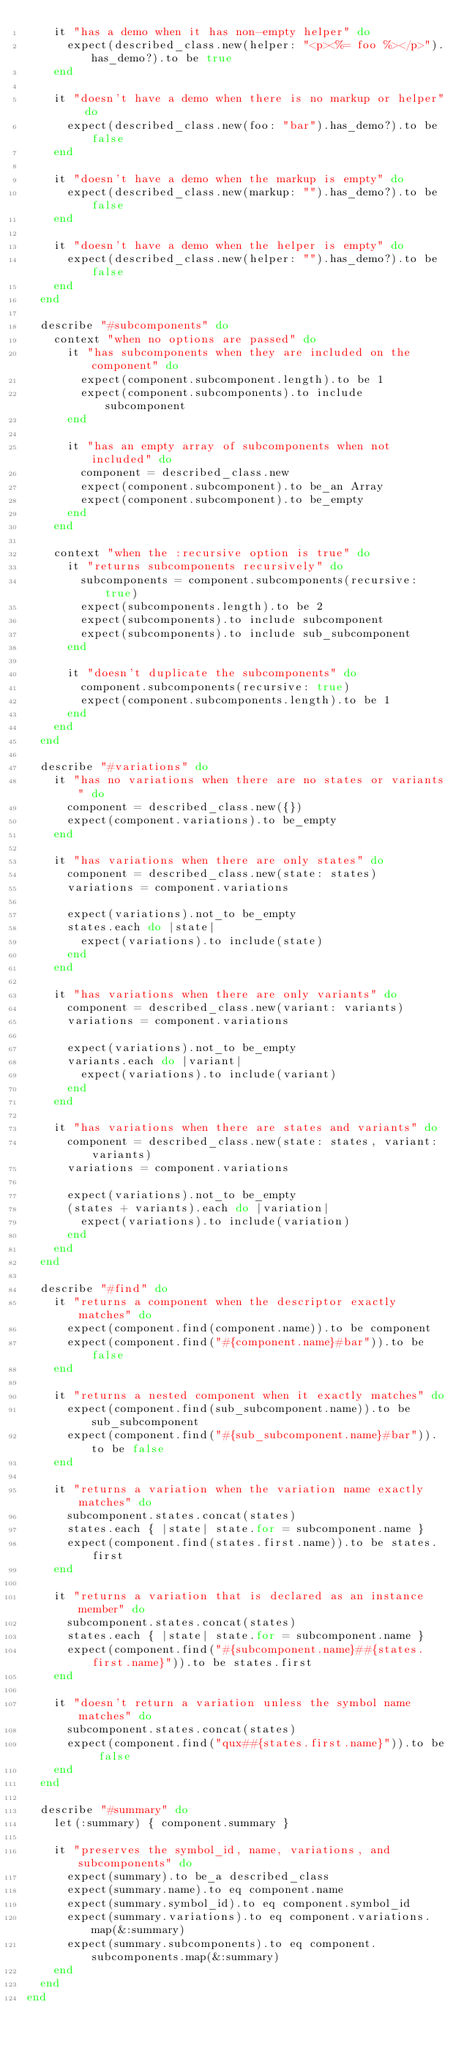Convert code to text. <code><loc_0><loc_0><loc_500><loc_500><_Ruby_>    it "has a demo when it has non-empty helper" do
      expect(described_class.new(helper: "<p><%= foo %></p>").has_demo?).to be true
    end

    it "doesn't have a demo when there is no markup or helper" do
      expect(described_class.new(foo: "bar").has_demo?).to be false
    end

    it "doesn't have a demo when the markup is empty" do
      expect(described_class.new(markup: "").has_demo?).to be false
    end

    it "doesn't have a demo when the helper is empty" do
      expect(described_class.new(helper: "").has_demo?).to be false
    end
  end

  describe "#subcomponents" do
    context "when no options are passed" do
      it "has subcomponents when they are included on the component" do
        expect(component.subcomponent.length).to be 1
        expect(component.subcomponents).to include subcomponent
      end

      it "has an empty array of subcomponents when not included" do
        component = described_class.new
        expect(component.subcomponent).to be_an Array
        expect(component.subcomponent).to be_empty
      end
    end

    context "when the :recursive option is true" do
      it "returns subcomponents recursively" do
        subcomponents = component.subcomponents(recursive: true)
        expect(subcomponents.length).to be 2
        expect(subcomponents).to include subcomponent
        expect(subcomponents).to include sub_subcomponent
      end

      it "doesn't duplicate the subcomponents" do
        component.subcomponents(recursive: true)
        expect(component.subcomponents.length).to be 1
      end
    end
  end

  describe "#variations" do
    it "has no variations when there are no states or variants" do
      component = described_class.new({})
      expect(component.variations).to be_empty
    end

    it "has variations when there are only states" do
      component = described_class.new(state: states)
      variations = component.variations

      expect(variations).not_to be_empty
      states.each do |state|
        expect(variations).to include(state)
      end
    end

    it "has variations when there are only variants" do
      component = described_class.new(variant: variants)
      variations = component.variations

      expect(variations).not_to be_empty
      variants.each do |variant|
        expect(variations).to include(variant)
      end
    end

    it "has variations when there are states and variants" do
      component = described_class.new(state: states, variant: variants)
      variations = component.variations

      expect(variations).not_to be_empty
      (states + variants).each do |variation|
        expect(variations).to include(variation)
      end
    end
  end

  describe "#find" do
    it "returns a component when the descriptor exactly matches" do
      expect(component.find(component.name)).to be component
      expect(component.find("#{component.name}#bar")).to be false
    end

    it "returns a nested component when it exactly matches" do
      expect(component.find(sub_subcomponent.name)).to be sub_subcomponent
      expect(component.find("#{sub_subcomponent.name}#bar")).to be false
    end

    it "returns a variation when the variation name exactly matches" do
      subcomponent.states.concat(states)
      states.each { |state| state.for = subcomponent.name }
      expect(component.find(states.first.name)).to be states.first
    end

    it "returns a variation that is declared as an instance member" do
      subcomponent.states.concat(states)
      states.each { |state| state.for = subcomponent.name }
      expect(component.find("#{subcomponent.name}##{states.first.name}")).to be states.first
    end

    it "doesn't return a variation unless the symbol name matches" do
      subcomponent.states.concat(states)
      expect(component.find("qux##{states.first.name}")).to be false
    end
  end

  describe "#summary" do
    let(:summary) { component.summary }

    it "preserves the symbol_id, name, variations, and subcomponents" do
      expect(summary).to be_a described_class
      expect(summary.name).to eq component.name
      expect(summary.symbol_id).to eq component.symbol_id
      expect(summary.variations).to eq component.variations.map(&:summary)
      expect(summary.subcomponents).to eq component.subcomponents.map(&:summary)
    end
  end
end
</code> 